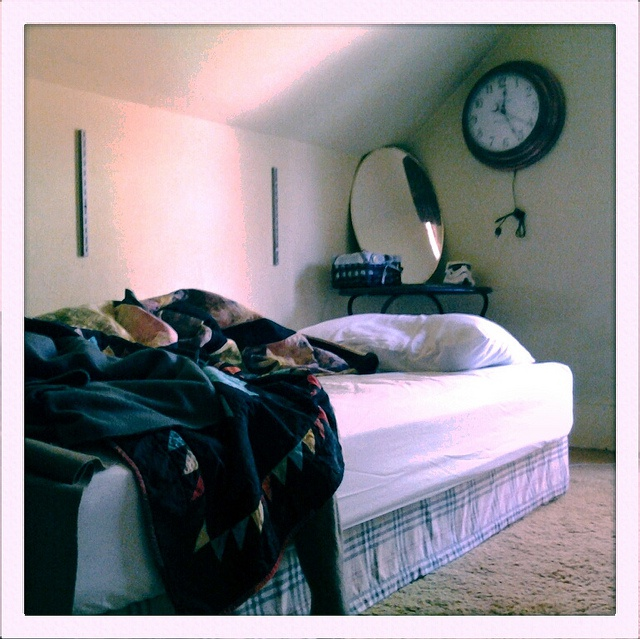Describe the objects in this image and their specific colors. I can see bed in gray, black, lavender, and darkgray tones and clock in gray, black, and teal tones in this image. 